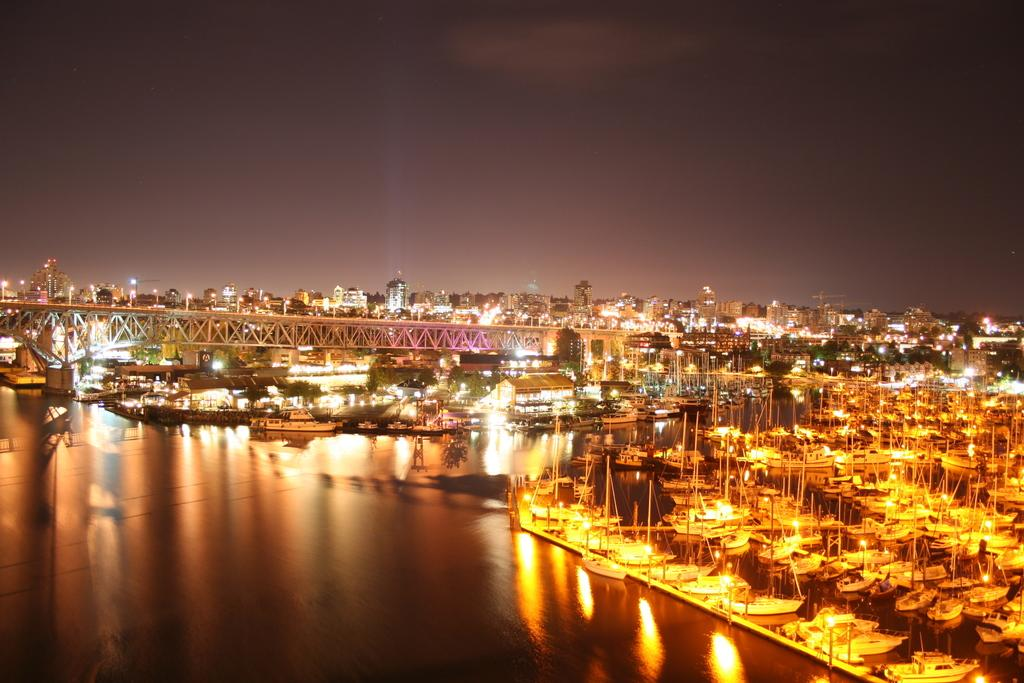What is present in the image that is not solid? There is water visible in the image. What type of vehicles can be seen in the image? There are boats in the image. What structure is present in the image that allows people or vehicles to cross over water? There is a bridge in the image. What can be seen in the distance in the image? There are buildings in the background of the image. What might be used for illumination in the image? There are lights visible in the image. What is visible at the top of the image? The sky is visible at the top of the image. What type of sand can be seen on the coach in the image? There is no coach or sand present in the image. How does the disgust in the image affect the water's appearance? There is no mention of disgust in the image, and it does not affect the water's appearance. 